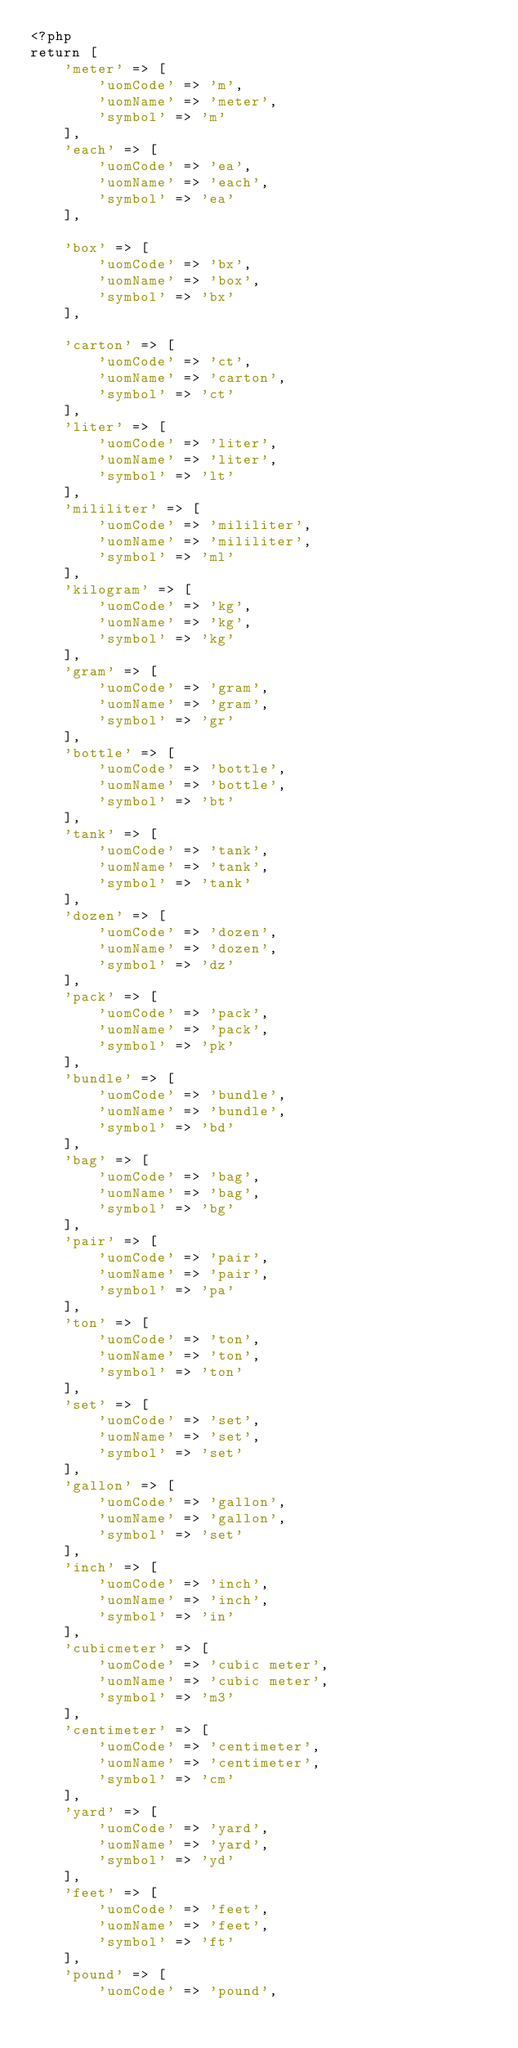<code> <loc_0><loc_0><loc_500><loc_500><_PHP_><?php
return [
    'meter' => [
        'uomCode' => 'm',
        'uomName' => 'meter',
        'symbol' => 'm'
    ],
    'each' => [
        'uomCode' => 'ea',
        'uomName' => 'each',
        'symbol' => 'ea'
    ],

    'box' => [
        'uomCode' => 'bx',
        'uomName' => 'box',
        'symbol' => 'bx'
    ],

    'carton' => [
        'uomCode' => 'ct',
        'uomName' => 'carton',
        'symbol' => 'ct'
    ],
    'liter' => [
        'uomCode' => 'liter',
        'uomName' => 'liter',
        'symbol' => 'lt'
    ],
    'mililiter' => [
        'uomCode' => 'mililiter',
        'uomName' => 'mililiter',
        'symbol' => 'ml'
    ],
    'kilogram' => [
        'uomCode' => 'kg',
        'uomName' => 'kg',
        'symbol' => 'kg'
    ],
    'gram' => [
        'uomCode' => 'gram',
        'uomName' => 'gram',
        'symbol' => 'gr'
    ],
    'bottle' => [
        'uomCode' => 'bottle',
        'uomName' => 'bottle',
        'symbol' => 'bt'
    ],
    'tank' => [
        'uomCode' => 'tank',
        'uomName' => 'tank',
        'symbol' => 'tank'
    ],
    'dozen' => [
        'uomCode' => 'dozen',
        'uomName' => 'dozen',
        'symbol' => 'dz'
    ],
    'pack' => [
        'uomCode' => 'pack',
        'uomName' => 'pack',
        'symbol' => 'pk'
    ],
    'bundle' => [
        'uomCode' => 'bundle',
        'uomName' => 'bundle',
        'symbol' => 'bd'
    ],
    'bag' => [
        'uomCode' => 'bag',
        'uomName' => 'bag',
        'symbol' => 'bg'
    ],
    'pair' => [
        'uomCode' => 'pair',
        'uomName' => 'pair',
        'symbol' => 'pa'
    ],
    'ton' => [
        'uomCode' => 'ton',
        'uomName' => 'ton',
        'symbol' => 'ton'
    ],
    'set' => [
        'uomCode' => 'set',
        'uomName' => 'set',
        'symbol' => 'set'
    ],
    'gallon' => [
        'uomCode' => 'gallon',
        'uomName' => 'gallon',
        'symbol' => 'set'
    ],
    'inch' => [
        'uomCode' => 'inch',
        'uomName' => 'inch',
        'symbol' => 'in'
    ],
    'cubicmeter' => [
        'uomCode' => 'cubic meter',
        'uomName' => 'cubic meter',
        'symbol' => 'm3'
    ],
    'centimeter' => [
        'uomCode' => 'centimeter',
        'uomName' => 'centimeter',
        'symbol' => 'cm'
    ],
    'yard' => [
        'uomCode' => 'yard',
        'uomName' => 'yard',
        'symbol' => 'yd'
    ],
    'feet' => [
        'uomCode' => 'feet',
        'uomName' => 'feet',
        'symbol' => 'ft'
    ],
    'pound' => [
        'uomCode' => 'pound',</code> 